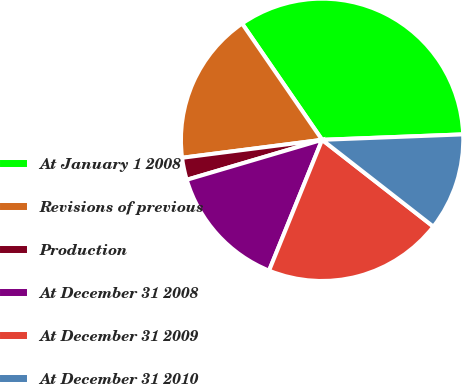Convert chart. <chart><loc_0><loc_0><loc_500><loc_500><pie_chart><fcel>At January 1 2008<fcel>Revisions of previous<fcel>Production<fcel>At December 31 2008<fcel>At December 31 2009<fcel>At December 31 2010<nl><fcel>33.98%<fcel>17.44%<fcel>2.54%<fcel>14.3%<fcel>20.59%<fcel>11.16%<nl></chart> 